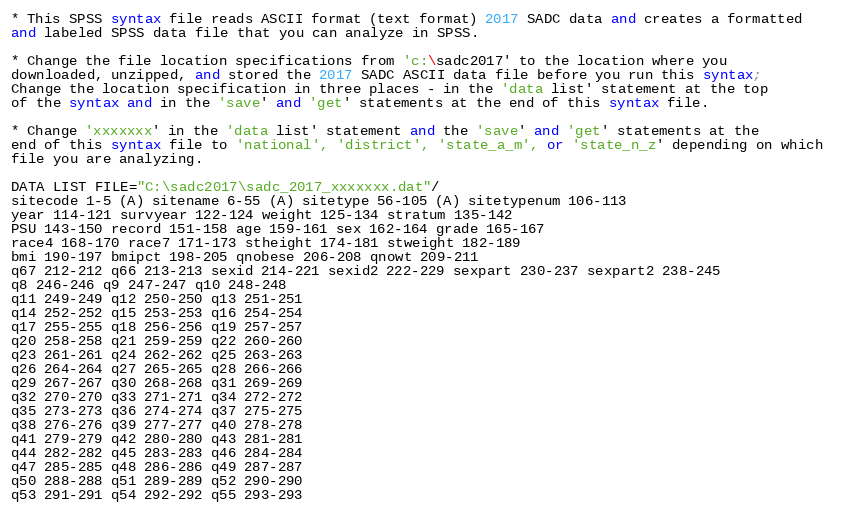Convert code to text. <code><loc_0><loc_0><loc_500><loc_500><_Scheme_>* This SPSS syntax file reads ASCII format (text format) 2017 SADC data and creates a formatted 
and labeled SPSS data file that you can analyze in SPSS.
 
* Change the file location specifications from 'c:\sadc2017' to the location where you 
downloaded, unzipped, and stored the 2017 SADC ASCII data file before you run this syntax; 
Change the location specification in three places - in the 'data list' statement at the top 
of the syntax and in the 'save' and 'get' statements at the end of this syntax file.

* Change 'xxxxxxx' in the 'data list' statement and the 'save' and 'get' statements at the 
end of this syntax file to 'national', 'district', 'state_a_m', or 'state_n_z' depending on which 
file you are analyzing.   

DATA LIST FILE="C:\sadc2017\sadc_2017_xxxxxxx.dat"/
sitecode 1-5 (A) sitename 6-55 (A) sitetype 56-105 (A) sitetypenum 106-113
year 114-121 survyear 122-124 weight 125-134 stratum 135-142
PSU 143-150 record 151-158 age 159-161 sex 162-164 grade 165-167
race4 168-170 race7 171-173 stheight 174-181 stweight 182-189
bmi 190-197 bmipct 198-205 qnobese 206-208 qnowt 209-211 
q67 212-212 q66 213-213 sexid 214-221 sexid2 222-229 sexpart 230-237 sexpart2 238-245
q8 246-246 q9 247-247 q10 248-248
q11 249-249 q12 250-250 q13 251-251 
q14 252-252 q15 253-253 q16 254-254 
q17 255-255 q18 256-256 q19 257-257 
q20 258-258 q21 259-259 q22 260-260 
q23 261-261 q24 262-262 q25 263-263 
q26 264-264 q27 265-265 q28 266-266 
q29 267-267 q30 268-268 q31 269-269 
q32 270-270 q33 271-271 q34 272-272 
q35 273-273 q36 274-274 q37 275-275 
q38 276-276 q39 277-277 q40 278-278 
q41 279-279 q42 280-280 q43 281-281 
q44 282-282 q45 283-283 q46 284-284 
q47 285-285 q48 286-286 q49 287-287 
q50 288-288 q51 289-289 q52 290-290 
q53 291-291 q54 292-292 q55 293-293 </code> 